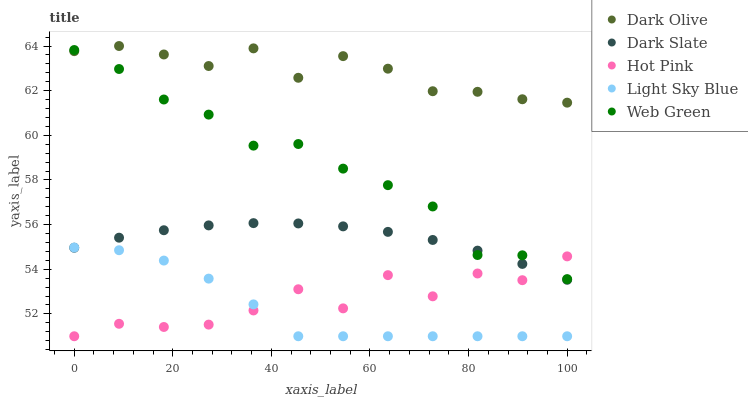Does Light Sky Blue have the minimum area under the curve?
Answer yes or no. Yes. Does Dark Olive have the maximum area under the curve?
Answer yes or no. Yes. Does Web Green have the minimum area under the curve?
Answer yes or no. No. Does Web Green have the maximum area under the curve?
Answer yes or no. No. Is Dark Slate the smoothest?
Answer yes or no. Yes. Is Hot Pink the roughest?
Answer yes or no. Yes. Is Dark Olive the smoothest?
Answer yes or no. No. Is Dark Olive the roughest?
Answer yes or no. No. Does Light Sky Blue have the lowest value?
Answer yes or no. Yes. Does Web Green have the lowest value?
Answer yes or no. No. Does Dark Olive have the highest value?
Answer yes or no. Yes. Does Web Green have the highest value?
Answer yes or no. No. Is Light Sky Blue less than Web Green?
Answer yes or no. Yes. Is Dark Olive greater than Light Sky Blue?
Answer yes or no. Yes. Does Web Green intersect Hot Pink?
Answer yes or no. Yes. Is Web Green less than Hot Pink?
Answer yes or no. No. Is Web Green greater than Hot Pink?
Answer yes or no. No. Does Light Sky Blue intersect Web Green?
Answer yes or no. No. 